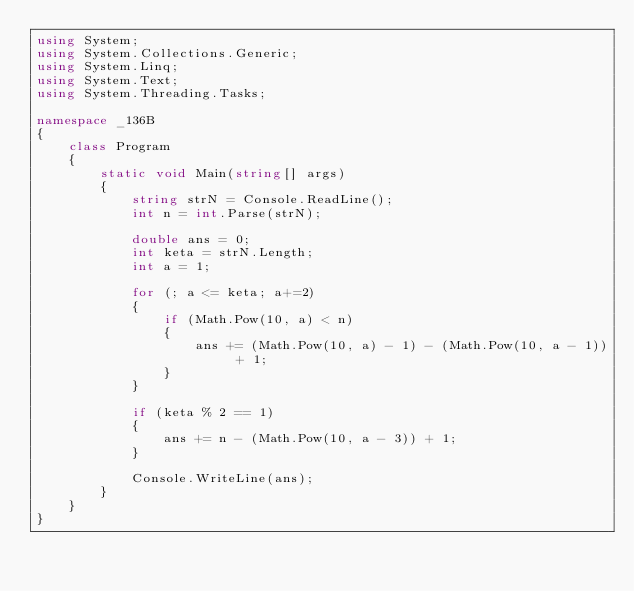<code> <loc_0><loc_0><loc_500><loc_500><_C#_>using System;
using System.Collections.Generic;
using System.Linq;
using System.Text;
using System.Threading.Tasks;

namespace _136B
{
    class Program
    {
        static void Main(string[] args)
        {
            string strN = Console.ReadLine();
            int n = int.Parse(strN);

            double ans = 0;
            int keta = strN.Length;
            int a = 1;

            for (; a <= keta; a+=2)
            {
                if (Math.Pow(10, a) < n)
                {
                    ans += (Math.Pow(10, a) - 1) - (Math.Pow(10, a - 1)) + 1;
                }
            }

            if (keta % 2 == 1)
            {
                ans += n - (Math.Pow(10, a - 3)) + 1;
            }

            Console.WriteLine(ans);
        }
    }
}</code> 